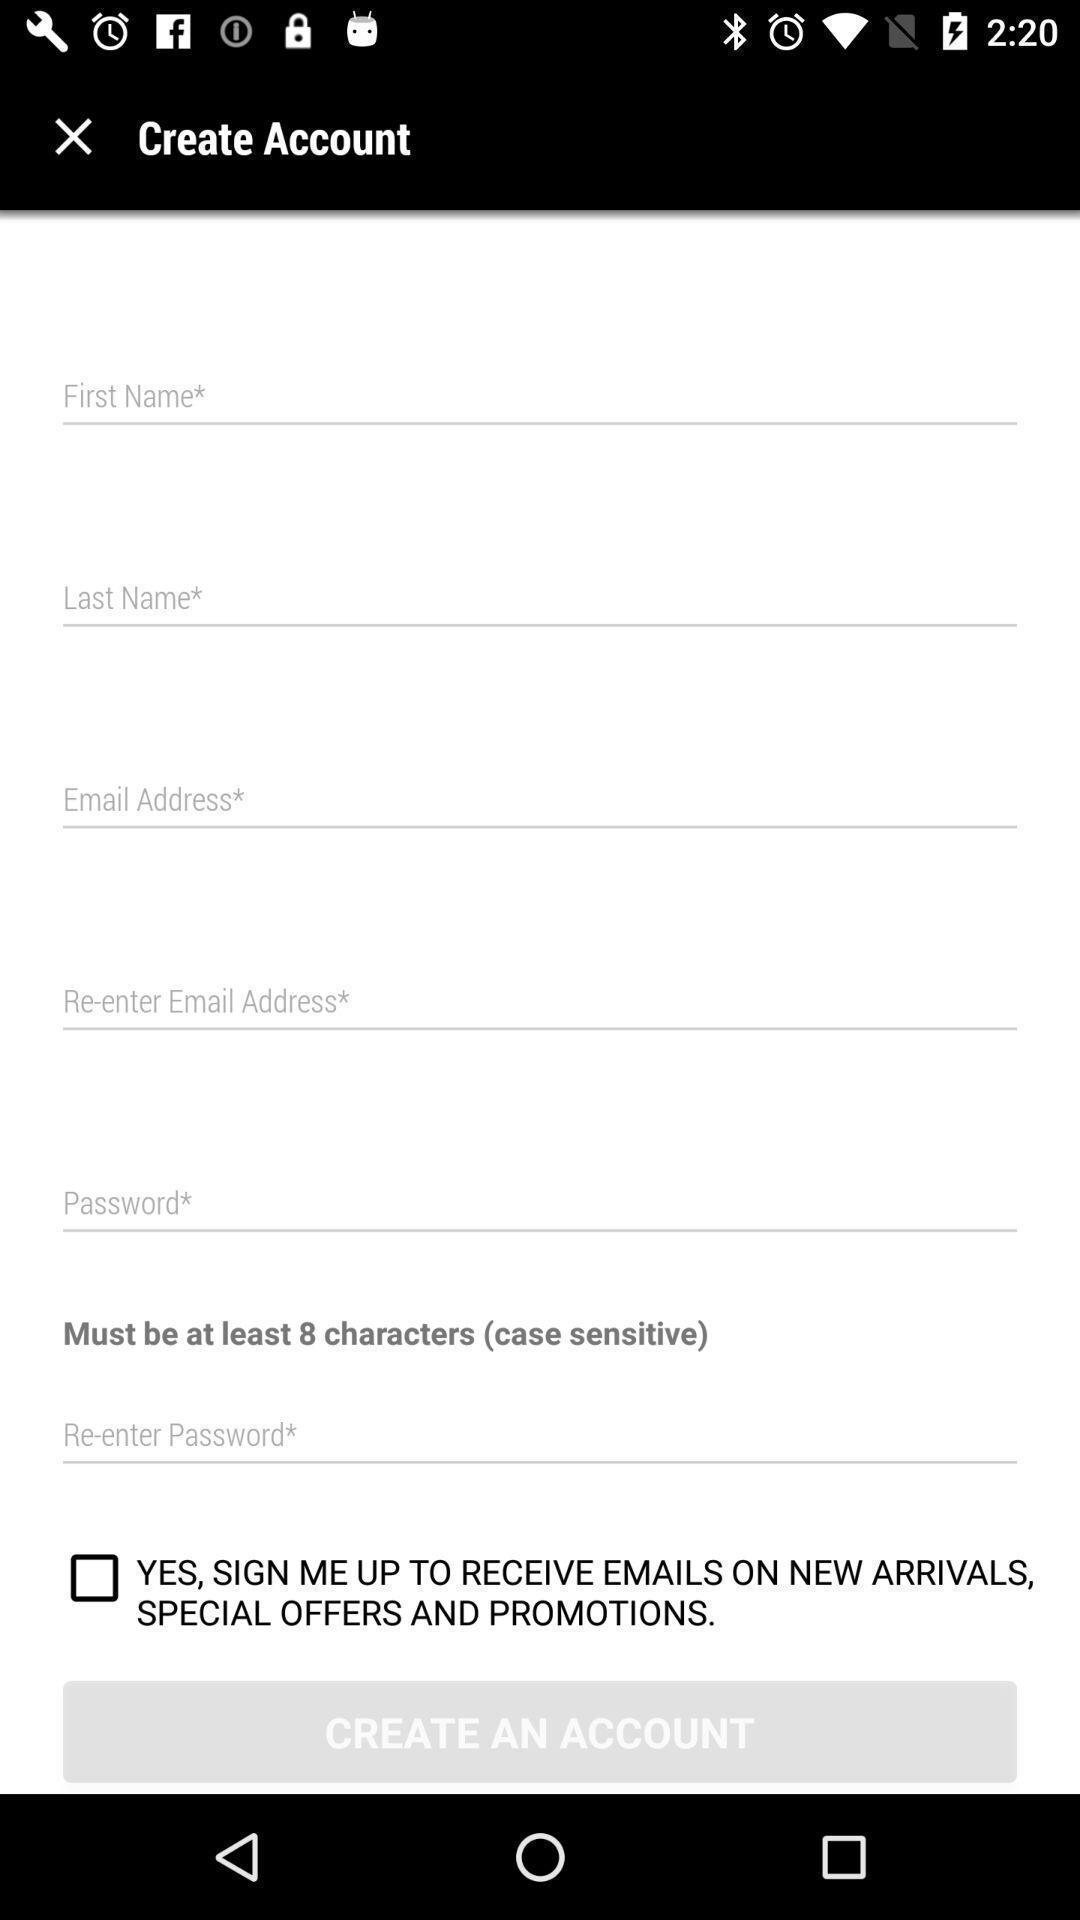Give me a narrative description of this picture. Page displaying with entry details to setup to create account. 